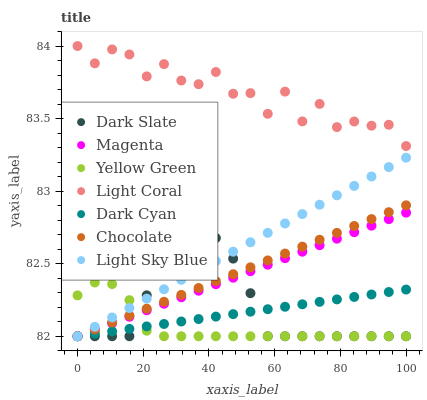Does Yellow Green have the minimum area under the curve?
Answer yes or no. Yes. Does Light Coral have the maximum area under the curve?
Answer yes or no. Yes. Does Chocolate have the minimum area under the curve?
Answer yes or no. No. Does Chocolate have the maximum area under the curve?
Answer yes or no. No. Is Chocolate the smoothest?
Answer yes or no. Yes. Is Light Coral the roughest?
Answer yes or no. Yes. Is Light Coral the smoothest?
Answer yes or no. No. Is Chocolate the roughest?
Answer yes or no. No. Does Yellow Green have the lowest value?
Answer yes or no. Yes. Does Light Coral have the lowest value?
Answer yes or no. No. Does Light Coral have the highest value?
Answer yes or no. Yes. Does Chocolate have the highest value?
Answer yes or no. No. Is Light Sky Blue less than Light Coral?
Answer yes or no. Yes. Is Light Coral greater than Magenta?
Answer yes or no. Yes. Does Dark Cyan intersect Yellow Green?
Answer yes or no. Yes. Is Dark Cyan less than Yellow Green?
Answer yes or no. No. Is Dark Cyan greater than Yellow Green?
Answer yes or no. No. Does Light Sky Blue intersect Light Coral?
Answer yes or no. No. 